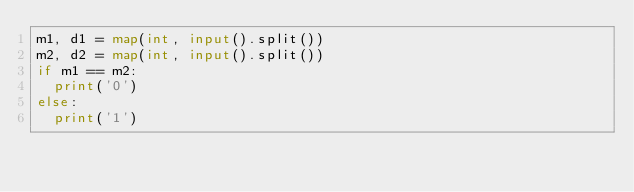<code> <loc_0><loc_0><loc_500><loc_500><_Python_>m1, d1 = map(int, input().split())
m2, d2 = map(int, input().split())
if m1 == m2:
  print('0')
else:
  print('1')</code> 